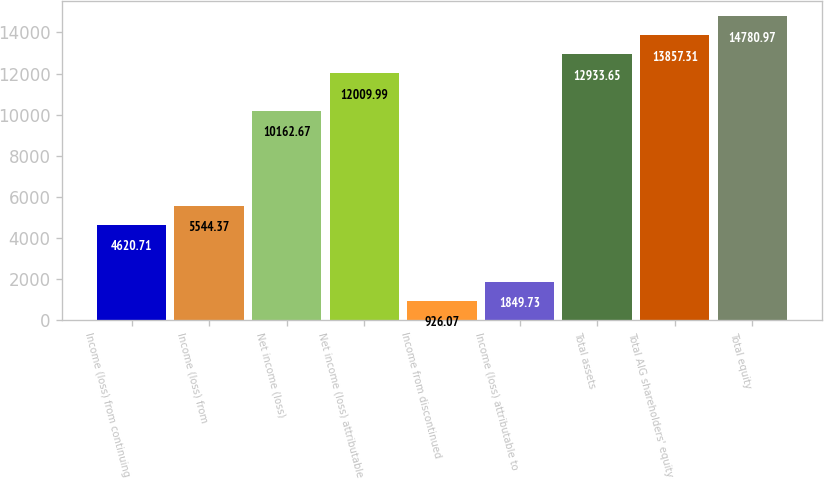Convert chart. <chart><loc_0><loc_0><loc_500><loc_500><bar_chart><fcel>Income (loss) from continuing<fcel>Income (loss) from<fcel>Net income (loss)<fcel>Net income (loss) attributable<fcel>Income from discontinued<fcel>Income (loss) attributable to<fcel>Total assets<fcel>Total AIG shareholders' equity<fcel>Total equity<nl><fcel>4620.71<fcel>5544.37<fcel>10162.7<fcel>12010<fcel>926.07<fcel>1849.73<fcel>12933.6<fcel>13857.3<fcel>14781<nl></chart> 